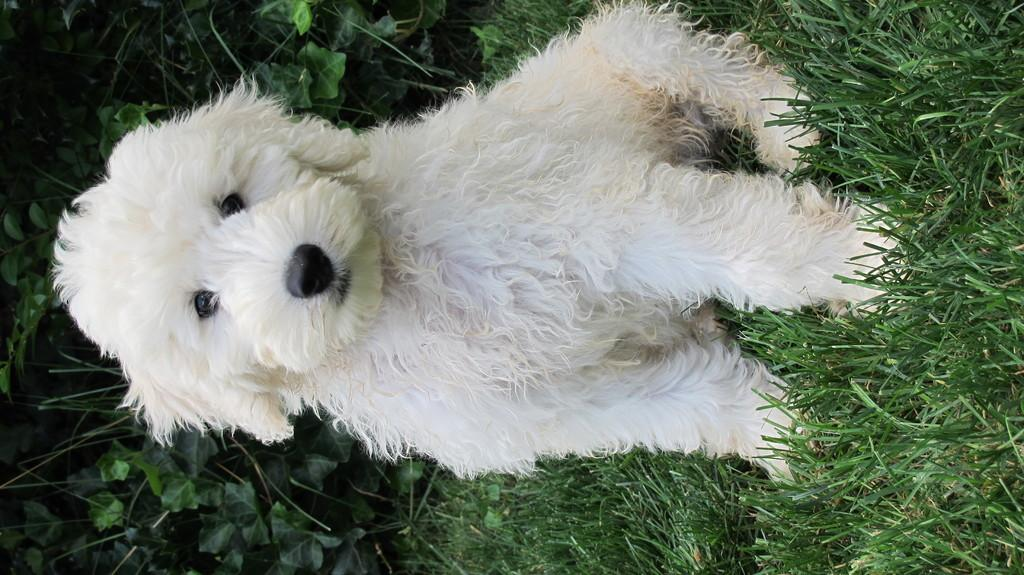What type of vegetation is present in the image? There is grass and plants in the image. What animal can be seen in the image? There is a dog in the image. What type of cake is being served in the garden in the image? There is no cake or garden present in the image; it features grass, plants, and a dog. 